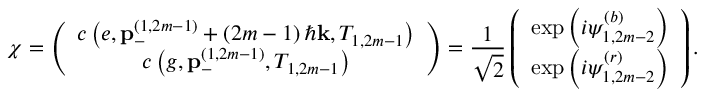<formula> <loc_0><loc_0><loc_500><loc_500>\chi = \left ( \begin{array} { c } { c \left ( e , p _ { - } ^ { \left ( 1 , 2 m - 1 \right ) } + \left ( 2 m - 1 \right ) \hbar { k } , T _ { 1 , 2 m - 1 } \right ) } \\ { c \left ( g , p _ { - } ^ { \left ( 1 , 2 m - 1 \right ) } , T _ { 1 , 2 m - 1 } \right ) } \end{array} \right ) = \frac { 1 } { \sqrt { 2 } } \left ( \begin{array} { c } { \exp \left ( i \psi _ { 1 , 2 m - 2 } ^ { \left ( b \right ) } \right ) } \\ { \exp \left ( i \psi _ { 1 , 2 m - 2 } ^ { \left ( r \right ) } \right ) } \end{array} \right ) .</formula> 